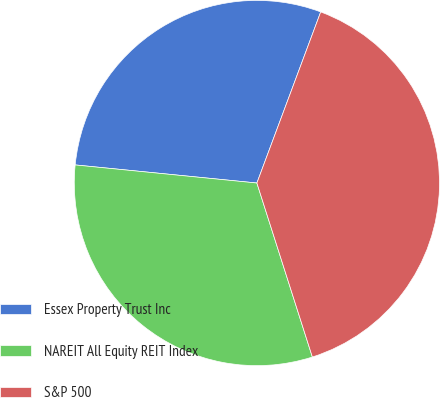Convert chart to OTSL. <chart><loc_0><loc_0><loc_500><loc_500><pie_chart><fcel>Essex Property Trust Inc<fcel>NAREIT All Equity REIT Index<fcel>S&P 500<nl><fcel>29.1%<fcel>31.49%<fcel>39.4%<nl></chart> 